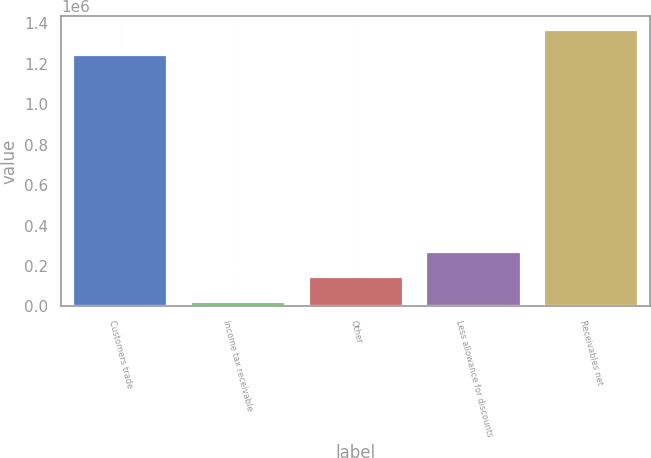<chart> <loc_0><loc_0><loc_500><loc_500><bar_chart><fcel>Customers trade<fcel>Income tax receivable<fcel>Other<fcel>Less allowance for discounts<fcel>Receivables net<nl><fcel>1.24353e+06<fcel>21835<fcel>145402<fcel>268969<fcel>1.3671e+06<nl></chart> 